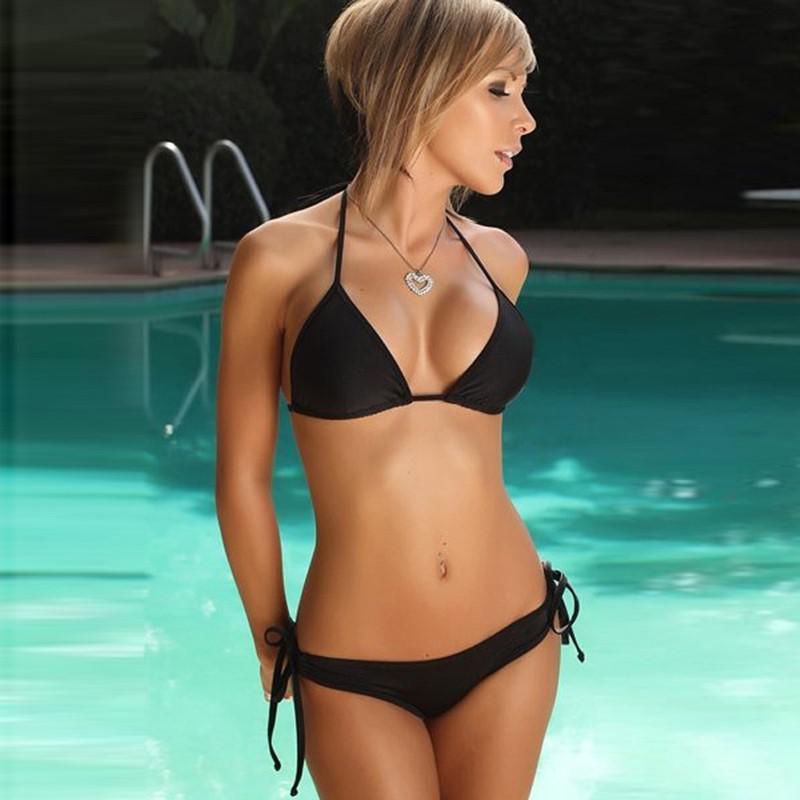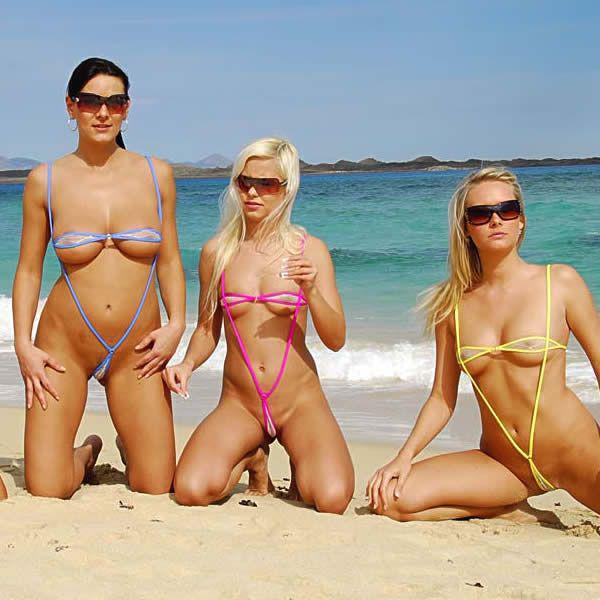The first image is the image on the left, the second image is the image on the right. Considering the images on both sides, is "There is exactly one woman in a swimsuit in each image." valid? Answer yes or no. No. The first image is the image on the left, the second image is the image on the right. Assess this claim about the two images: "In the left image, the bikini is black.". Correct or not? Answer yes or no. Yes. 